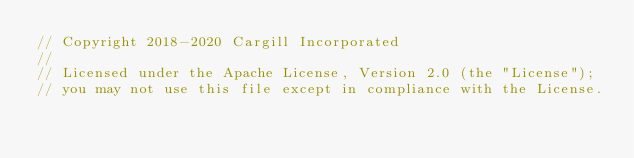Convert code to text. <code><loc_0><loc_0><loc_500><loc_500><_Rust_>// Copyright 2018-2020 Cargill Incorporated
//
// Licensed under the Apache License, Version 2.0 (the "License");
// you may not use this file except in compliance with the License.</code> 